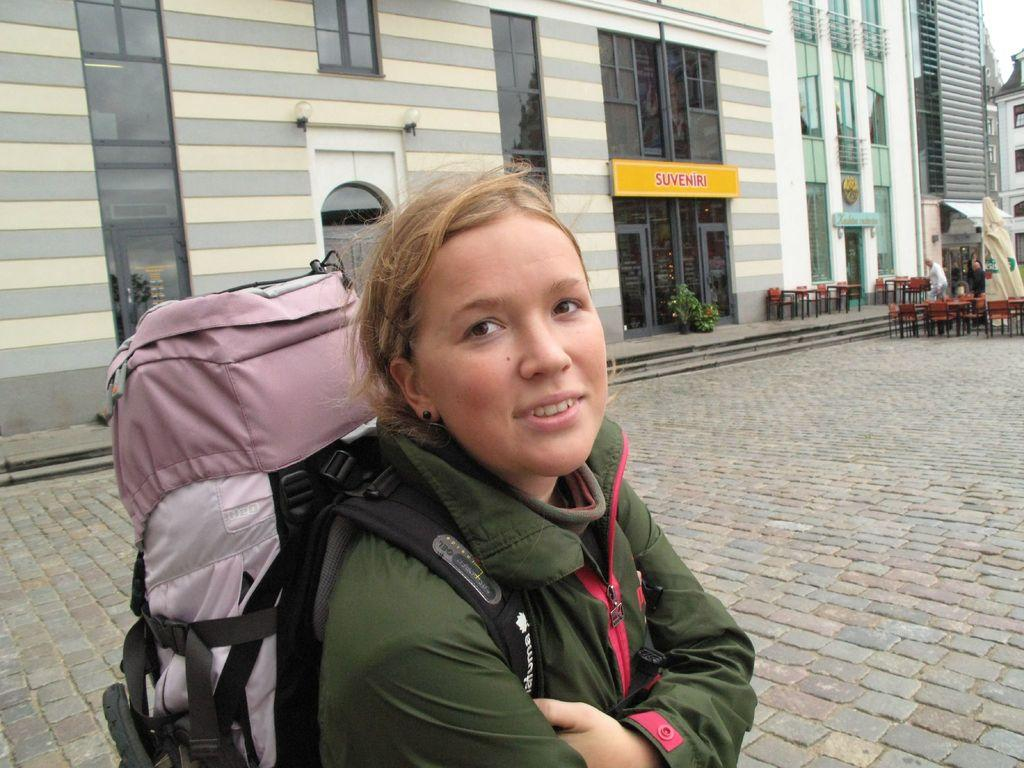<image>
Present a compact description of the photo's key features. a girl with a building in the back with the name Suveniri on it 